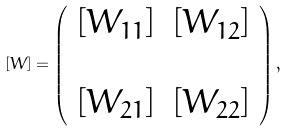<formula> <loc_0><loc_0><loc_500><loc_500>\left [ W \right ] = \left ( \begin{array} { l r } \left [ W _ { 1 1 } \right ] & \left [ W _ { 1 2 } \right ] \\ & \\ \left [ W _ { 2 1 } \right ] & \left [ W _ { 2 2 } \right ] \end{array} \right ) ,</formula> 